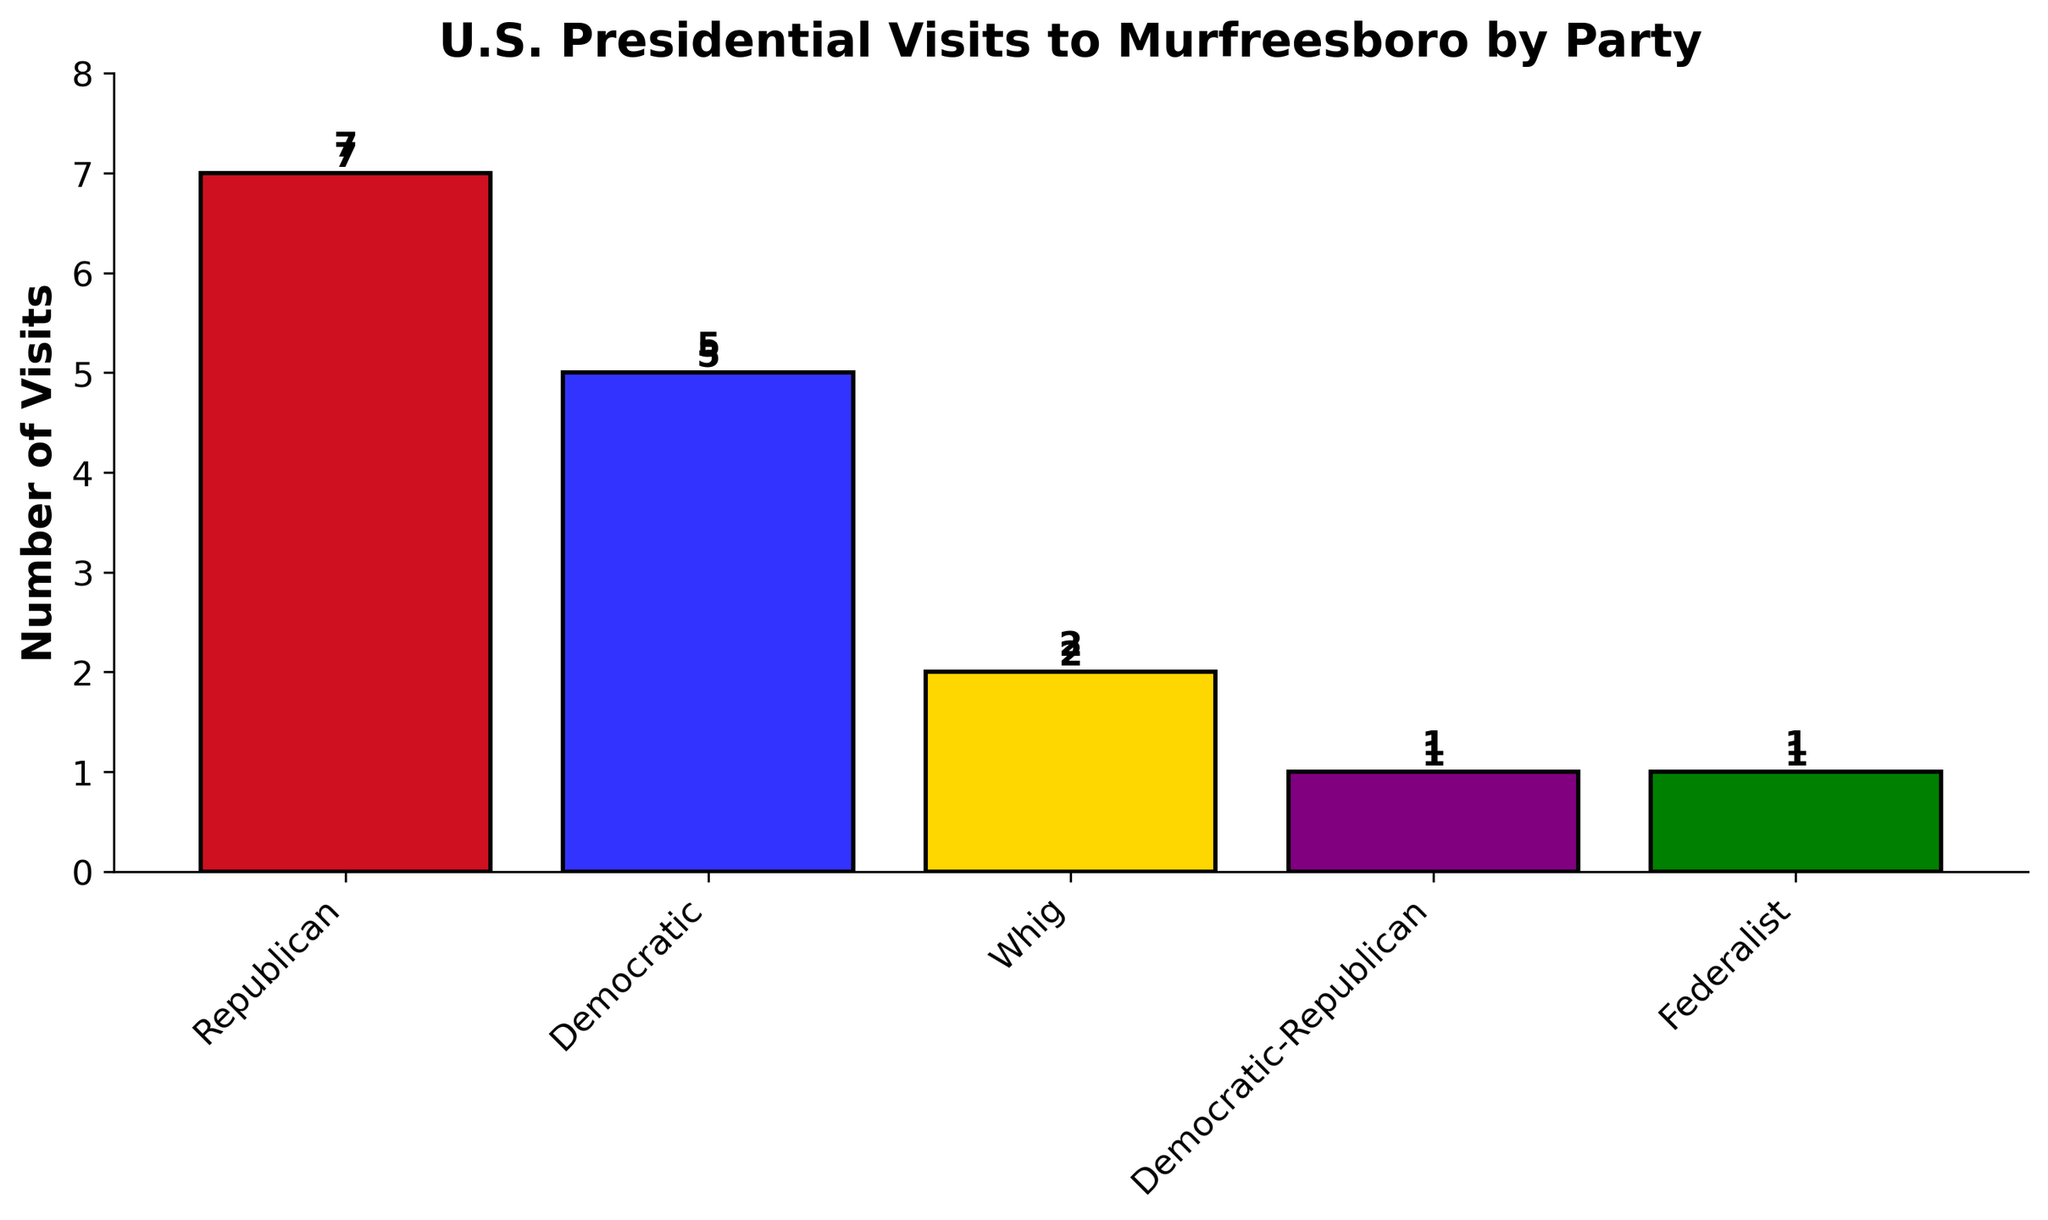What's the total number of visits made by U.S. presidents to Murfreesboro? To find the total number of visits, sum up the number of visits from each party. Sum = 7 (Republican) + 5 (Democratic) + 2 (Whig) + 1 (Democratic-Republican) + 1 (Federalist) = 16
Answer: 16 Which political party has the highest number of presidential visits to Murfreesboro? By observing the heights of the bars, the Republican party has the highest number of visits with 7 visits.
Answer: Republican How many visits occurred from parties other than the Democratic and Republican parties combined? Sum the visits from Whig, Democratic-Republican, and Federalist parties. Sum = 2 (Whig) + 1 (Democratic-Republican) + 1 (Federalist) = 4
Answer: 4 What is the difference in the number of visits between the Republican and Democratic parties? The Republican party has 7 visits and the Democratic party has 5 visits. Difference = 7 - 5 = 2
Answer: 2 Which two parties have the same number of presidential visits, and what is that number? By looking at the bars, the Democratic-Republican and Federalist parties have the same number of visits, which is 1.
Answer: Democratic-Republican and Federalist, 1 Among the Whig, Democratic-Republican, and Federalist parties, which has the highest number of visits? By comparing the heights of the bars for these parties, the Whig party has the highest number of visits with a count of 2.
Answer: Whig What fraction of the total visits were made by the Democratic party? Use the formula: Fraction = (Number of visits by Democratic party) / (Total number of visits). Fraction = 5 / 16 = 5/16
Answer: 5/16 What is the combined number of visits by the Federalist and Democratic-Republican parties? Add the visits from the Federalist and Democratic-Republican parties. Sum = 1 (Federalist) + 1 (Democratic-Republican) = 2
Answer: 2 How do the numbers of visits from the Republican and Democratic parties compare? The Republican party has 7 visits, while the Democratic party has 5 visits. Therefore, the Republican party has 2 more visits than the Democratic party.
Answer: Republican has 2 more What is the average number of visits per party? To find the average, divide the total number of visits by the number of parties. Average = Total visits / Number of parties = 16 / 5 = 3.2
Answer: 3.2 